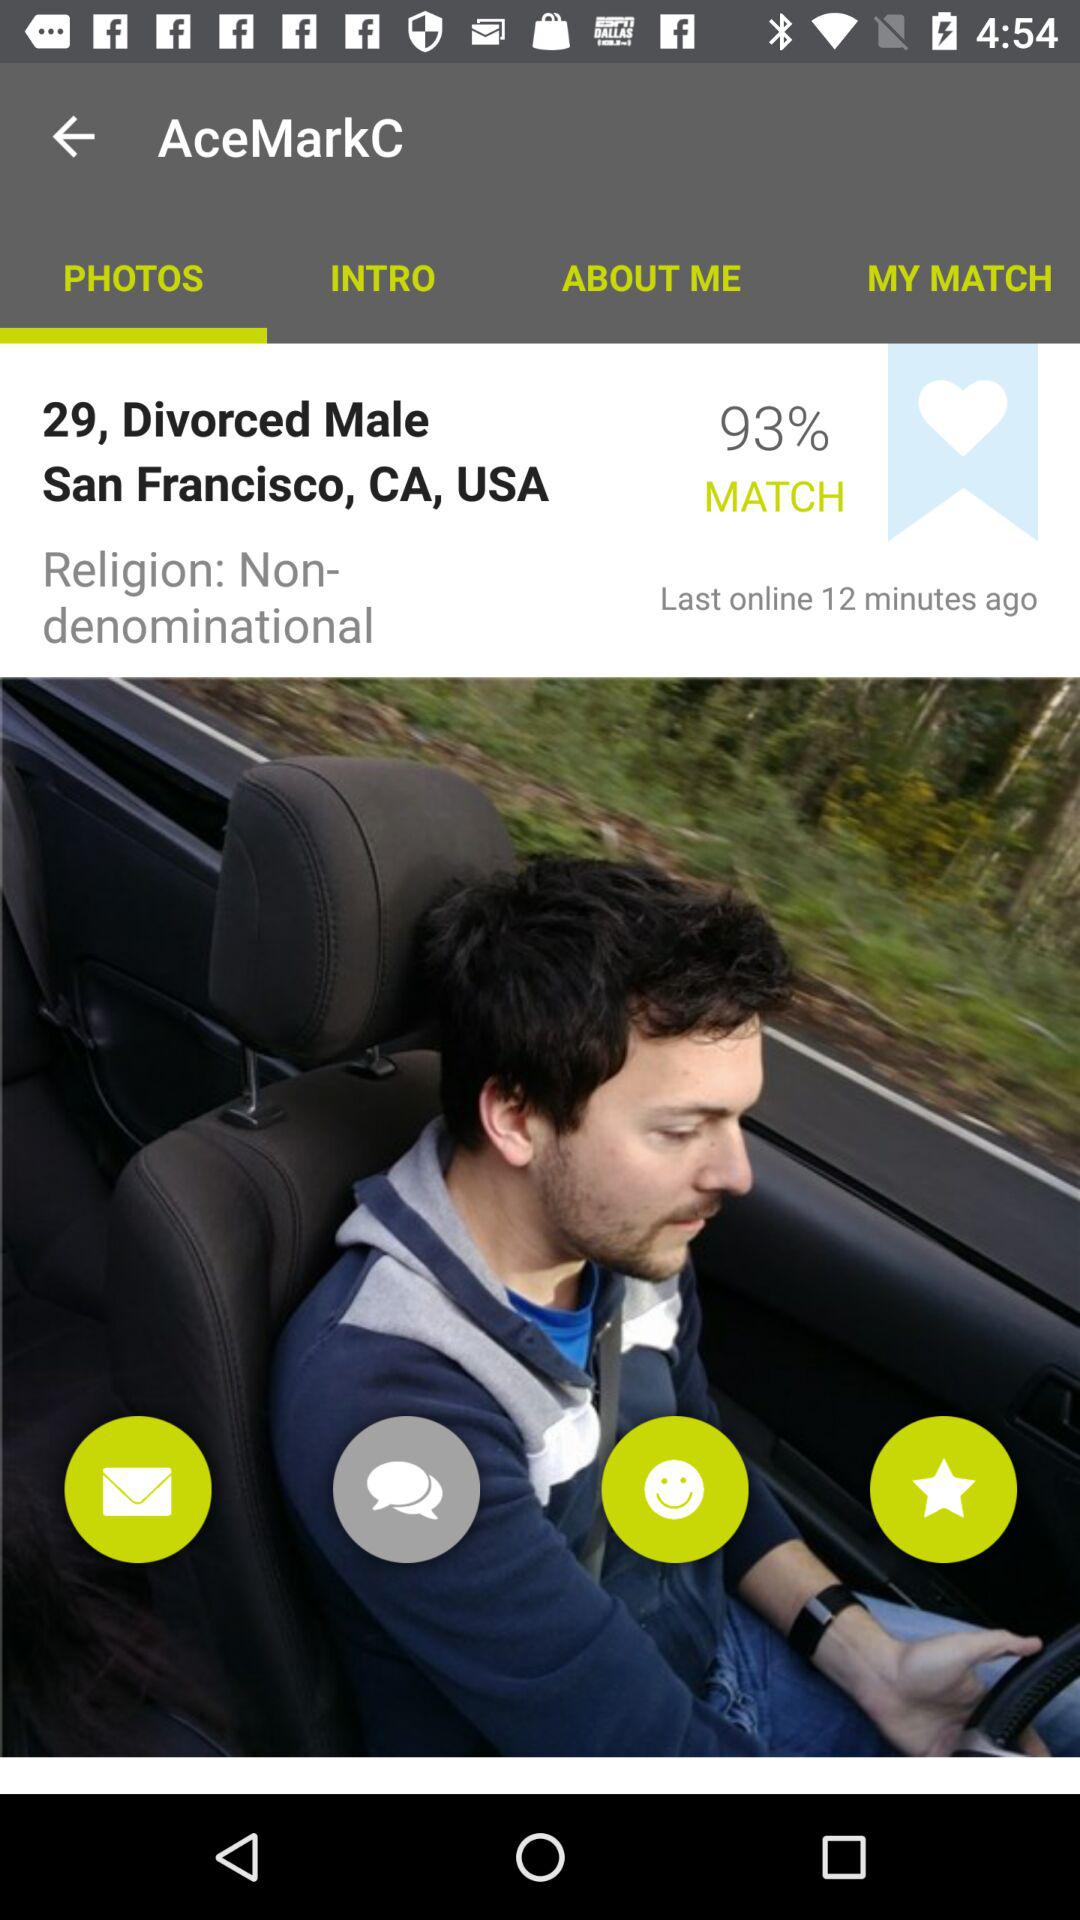What is the gender? The gender is male. 